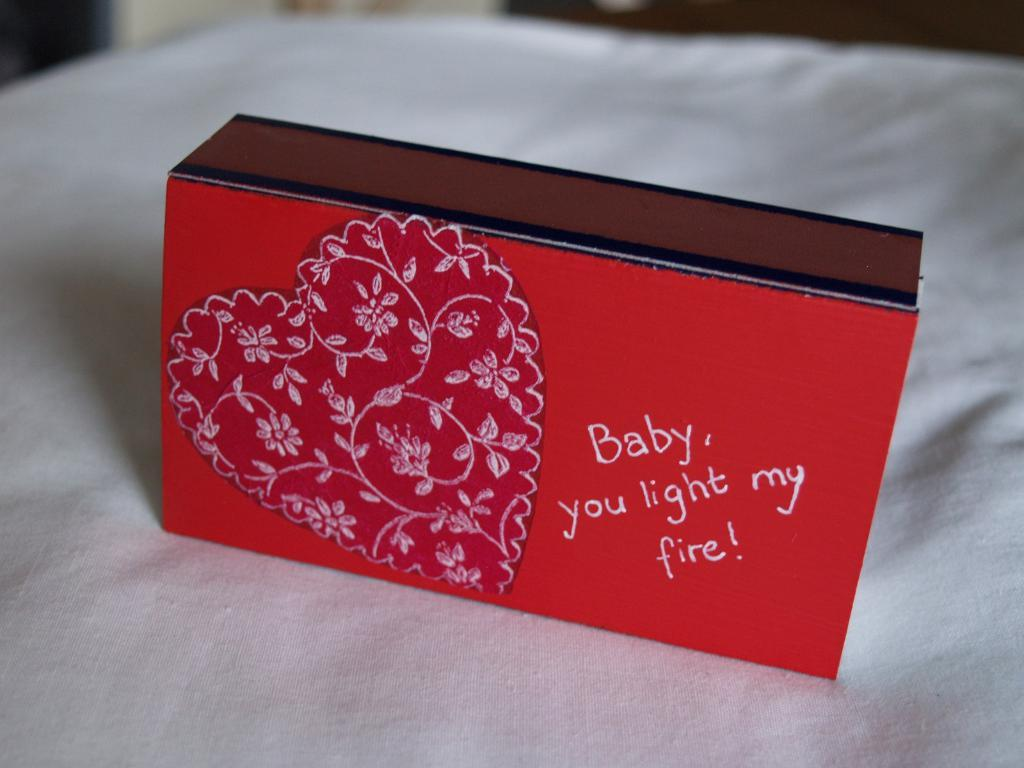<image>
Relay a brief, clear account of the picture shown. A box has a heart on it and says Baby, you light my fire. 